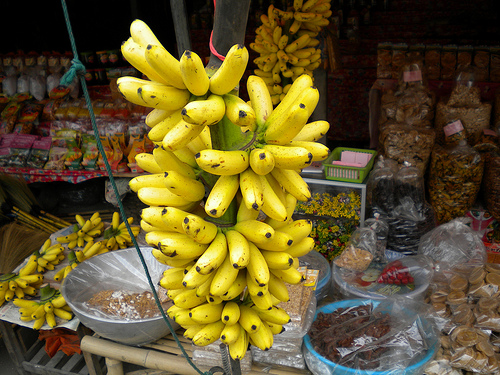Please provide a short description for this region: [0.54, 0.45, 0.62, 0.53]. This region also shows part of a bunch of ripe yellow bananas, showcasing their freshness and appealing texture, indicative of a tropical setting. 